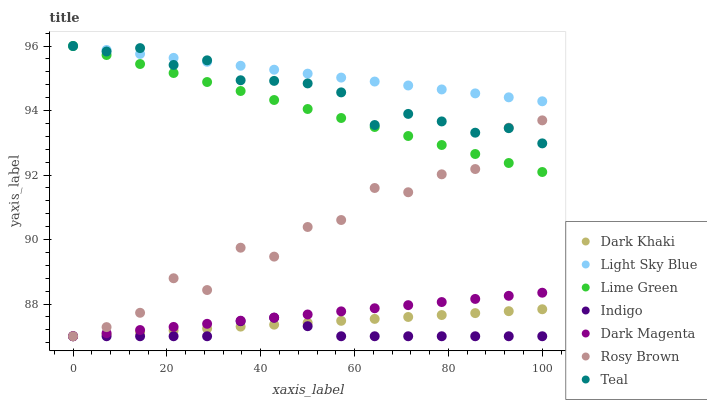Does Indigo have the minimum area under the curve?
Answer yes or no. Yes. Does Light Sky Blue have the maximum area under the curve?
Answer yes or no. Yes. Does Dark Magenta have the minimum area under the curve?
Answer yes or no. No. Does Dark Magenta have the maximum area under the curve?
Answer yes or no. No. Is Dark Magenta the smoothest?
Answer yes or no. Yes. Is Rosy Brown the roughest?
Answer yes or no. Yes. Is Rosy Brown the smoothest?
Answer yes or no. No. Is Dark Magenta the roughest?
Answer yes or no. No. Does Indigo have the lowest value?
Answer yes or no. Yes. Does Light Sky Blue have the lowest value?
Answer yes or no. No. Does Lime Green have the highest value?
Answer yes or no. Yes. Does Dark Magenta have the highest value?
Answer yes or no. No. Is Dark Khaki less than Lime Green?
Answer yes or no. Yes. Is Light Sky Blue greater than Dark Khaki?
Answer yes or no. Yes. Does Teal intersect Light Sky Blue?
Answer yes or no. Yes. Is Teal less than Light Sky Blue?
Answer yes or no. No. Is Teal greater than Light Sky Blue?
Answer yes or no. No. Does Dark Khaki intersect Lime Green?
Answer yes or no. No. 